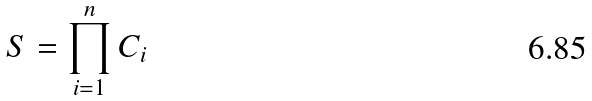Convert formula to latex. <formula><loc_0><loc_0><loc_500><loc_500>S = \prod _ { i = 1 } ^ { n } C _ { i }</formula> 